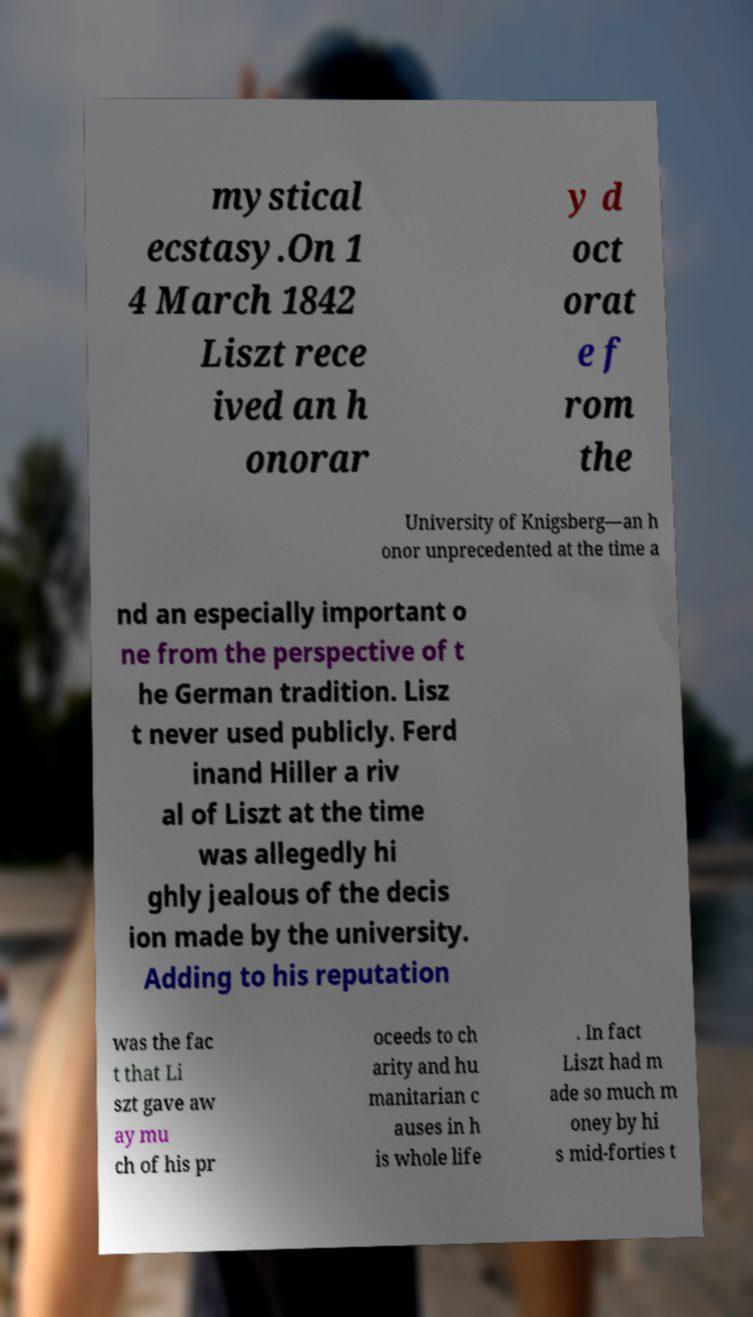Could you extract and type out the text from this image? mystical ecstasy.On 1 4 March 1842 Liszt rece ived an h onorar y d oct orat e f rom the University of Knigsberg—an h onor unprecedented at the time a nd an especially important o ne from the perspective of t he German tradition. Lisz t never used publicly. Ferd inand Hiller a riv al of Liszt at the time was allegedly hi ghly jealous of the decis ion made by the university. Adding to his reputation was the fac t that Li szt gave aw ay mu ch of his pr oceeds to ch arity and hu manitarian c auses in h is whole life . In fact Liszt had m ade so much m oney by hi s mid-forties t 